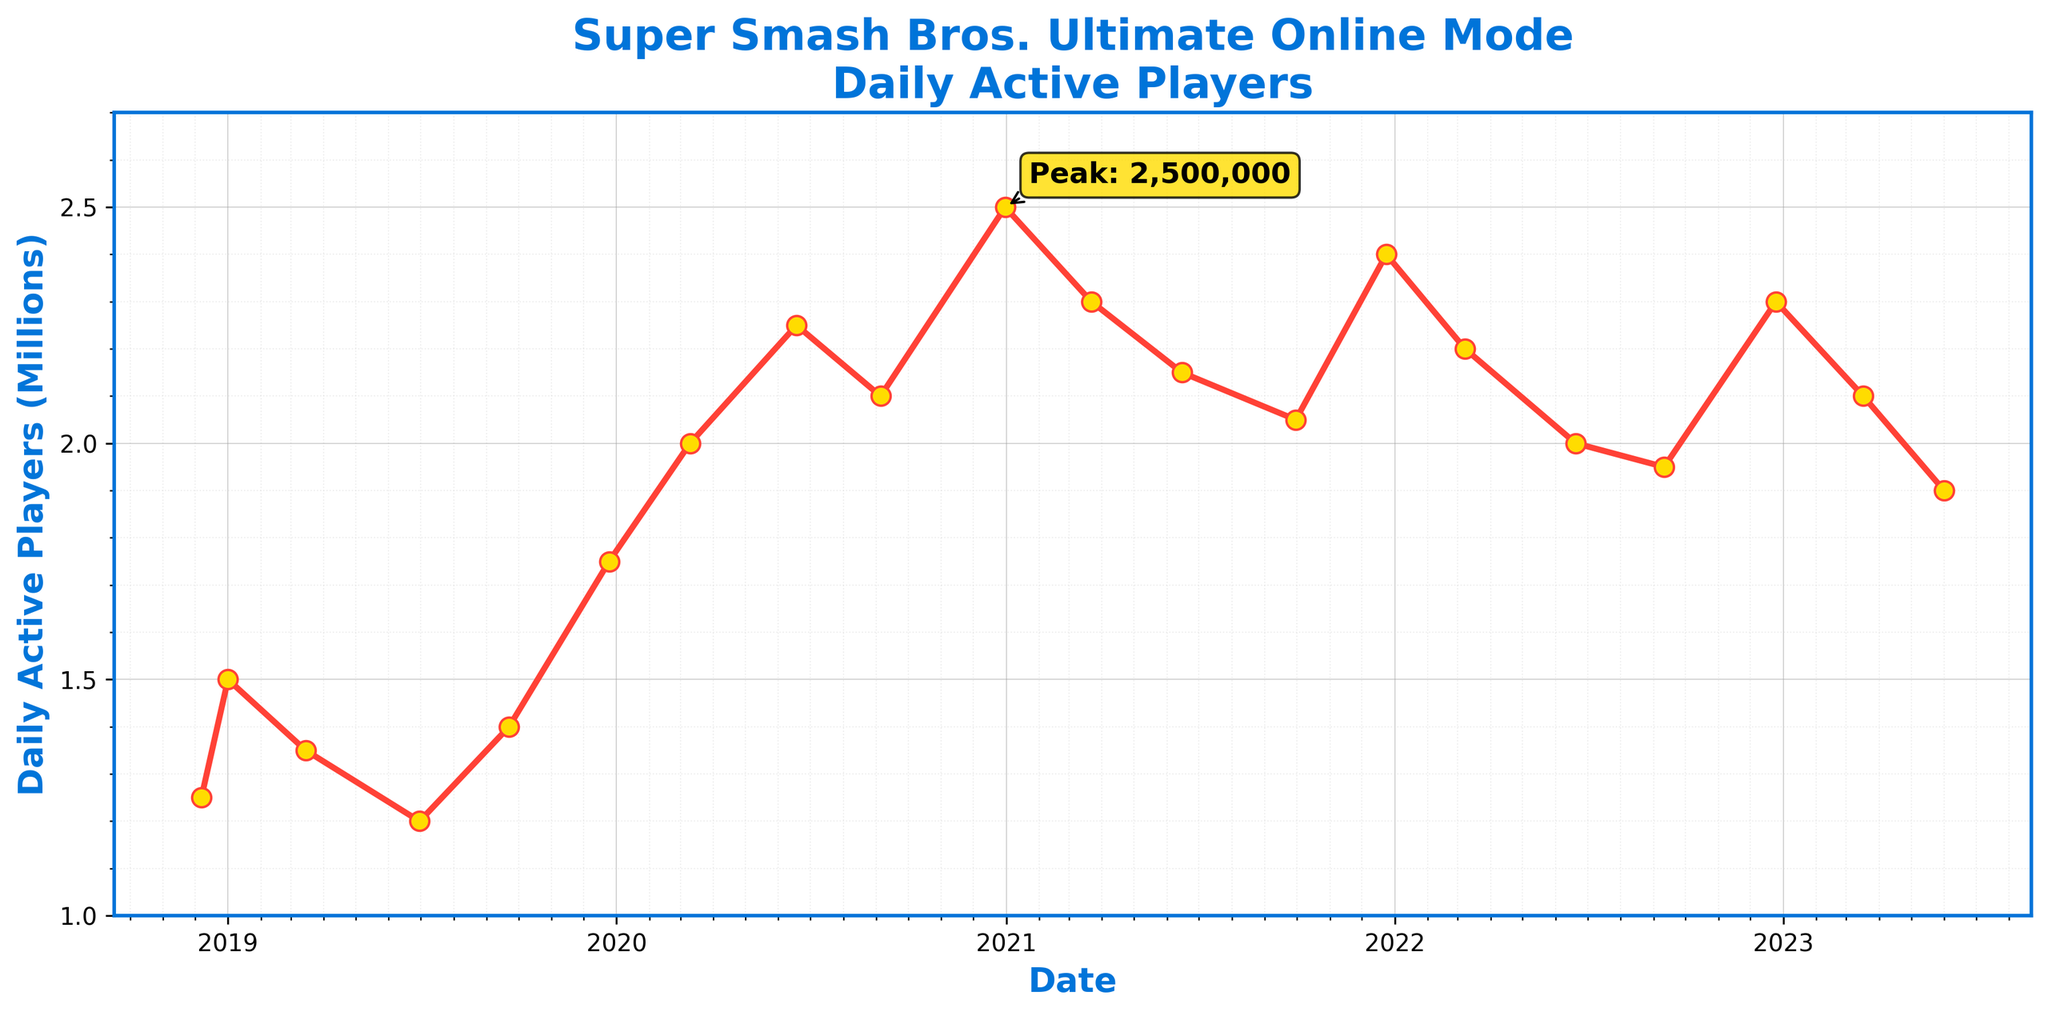What's the date with the highest Daily Active Players count, and what was the count? The peak point is annotated on the graph. The highest player count was at the end of 2020, specifically around December 31, 2020, with 2.5 million players.
Answer: December 31, 2020, 2.5 million How did the number of daily active players change from launch to the end of the first year? At launch (2018-12-07), the player count was 1.25 million, and at the end of the first year (2019-12-25), it was 1.75 million. The difference is 1.75 million - 1.25 million = 0.5 million.
Answer: Increased by 0.5 million Which period saw the maximum increase in daily active players between two consecutive data points? For each consecutive pair, compute the increase: 
1.25M to 1.5M = 0.25M
1.5M to 1.35M = -0.15M
1.35M to 1.2M = -0.15M
1.2M to 1.4M = 0.2M
1.4M to 1.75M = 0.35M
1.75M to 2.0M = 0.25M
2.0M to 2.25M = 0.25M
Maximum increase is between 2019-12-25 and 2020-03-10
Answer: 2019-12-25 to 2020-03-10 What is the average daily active player count in 2021? The counts for 2021 are: 2.3M (March), 2.15M (June), 2.05M (September), 2.4M (December). The average is (2.3 + 2.15 + 2.05 + 2.4) / 4 = 2.225 million.
Answer: 2.225 million How does the player count on December 25, 2019, compare to December 25, 2020? The player count on 2019-12-25 was 1.75 million, and on 2020-12-25, it was 2.5 million. Comparison: 2.5 million > 1.75 million.
Answer: 2020 > 2019 What trend can be observed around holiday seasons like Christmas? For two consecutive years, there are spikes in player count around December 25, 2019 (1.75 million), and December 25, 2020 (2.5 million), indicating increased activity.
Answer: Spike in player count How did the player count change during the first wave of COVID-19 lockdowns around March 2020? In March 2020, the player count rose from 1.75 million (2019-12-25) to 2.0 million (2020-03-10), showing an increase.
Answer: Increase during lockdown What's the difference in the daily active players between March 22, 2021, and June 1, 2023? On March 22, 2021, the count was 2.3 million, and on June 1, 2023, it was 1.9 million. The difference is 2.3 million - 1.9 million = 0.4 million.
Answer: Decrease by 0.4 million 